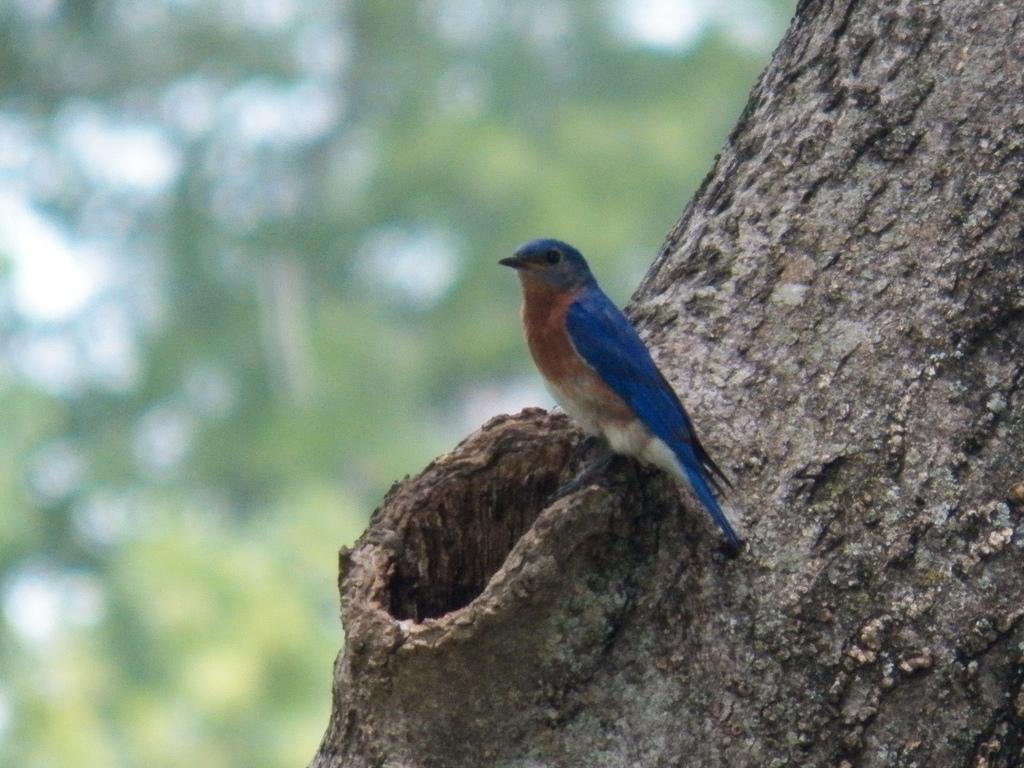What type of animal is in the image? There is a small bird in the image. Can you describe the bird's coloring? The bird has brown and blue coloring. Where is the bird located in the image? The bird is sitting on a tree trunk. What can be seen in the background of the image? There is a green blur background in the image. What type of pie is the bird eating in the image? There is no pie present in the image; the bird is sitting on a tree trunk. What substance is the bird using to wash itself in the image? There is no indication in the image that the bird is washing itself or using any substance for that purpose. 